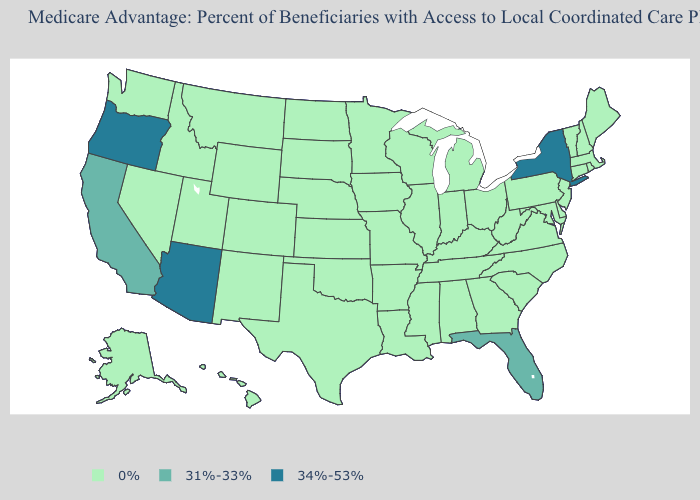Does the map have missing data?
Answer briefly. No. What is the highest value in the South ?
Quick response, please. 31%-33%. What is the value of North Carolina?
Quick response, please. 0%. Name the states that have a value in the range 0%?
Answer briefly. Alaska, Alabama, Arkansas, Colorado, Connecticut, Delaware, Georgia, Hawaii, Iowa, Idaho, Illinois, Indiana, Kansas, Kentucky, Louisiana, Massachusetts, Maryland, Maine, Michigan, Minnesota, Missouri, Mississippi, Montana, North Carolina, North Dakota, Nebraska, New Hampshire, New Jersey, New Mexico, Nevada, Ohio, Oklahoma, Pennsylvania, Rhode Island, South Carolina, South Dakota, Tennessee, Texas, Utah, Virginia, Vermont, Washington, Wisconsin, West Virginia, Wyoming. Name the states that have a value in the range 31%-33%?
Quick response, please. California, Florida. Does Indiana have a lower value than Oregon?
Be succinct. Yes. What is the value of North Carolina?
Concise answer only. 0%. Name the states that have a value in the range 0%?
Short answer required. Alaska, Alabama, Arkansas, Colorado, Connecticut, Delaware, Georgia, Hawaii, Iowa, Idaho, Illinois, Indiana, Kansas, Kentucky, Louisiana, Massachusetts, Maryland, Maine, Michigan, Minnesota, Missouri, Mississippi, Montana, North Carolina, North Dakota, Nebraska, New Hampshire, New Jersey, New Mexico, Nevada, Ohio, Oklahoma, Pennsylvania, Rhode Island, South Carolina, South Dakota, Tennessee, Texas, Utah, Virginia, Vermont, Washington, Wisconsin, West Virginia, Wyoming. What is the value of West Virginia?
Write a very short answer. 0%. Does West Virginia have the lowest value in the USA?
Answer briefly. Yes. Name the states that have a value in the range 31%-33%?
Quick response, please. California, Florida. What is the highest value in states that border Virginia?
Give a very brief answer. 0%. What is the value of New Hampshire?
Answer briefly. 0%. Which states hav the highest value in the Northeast?
Concise answer only. New York. 